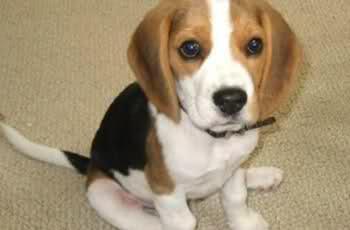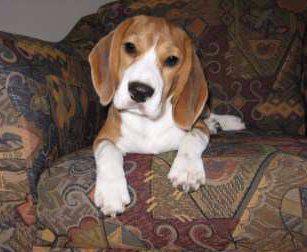The first image is the image on the left, the second image is the image on the right. Evaluate the accuracy of this statement regarding the images: "One dog is chewing on something.". Is it true? Answer yes or no. No. The first image is the image on the left, the second image is the image on the right. For the images shown, is this caption "Each image shows one young beagle, and no beagle is in a reclining pose." true? Answer yes or no. No. 